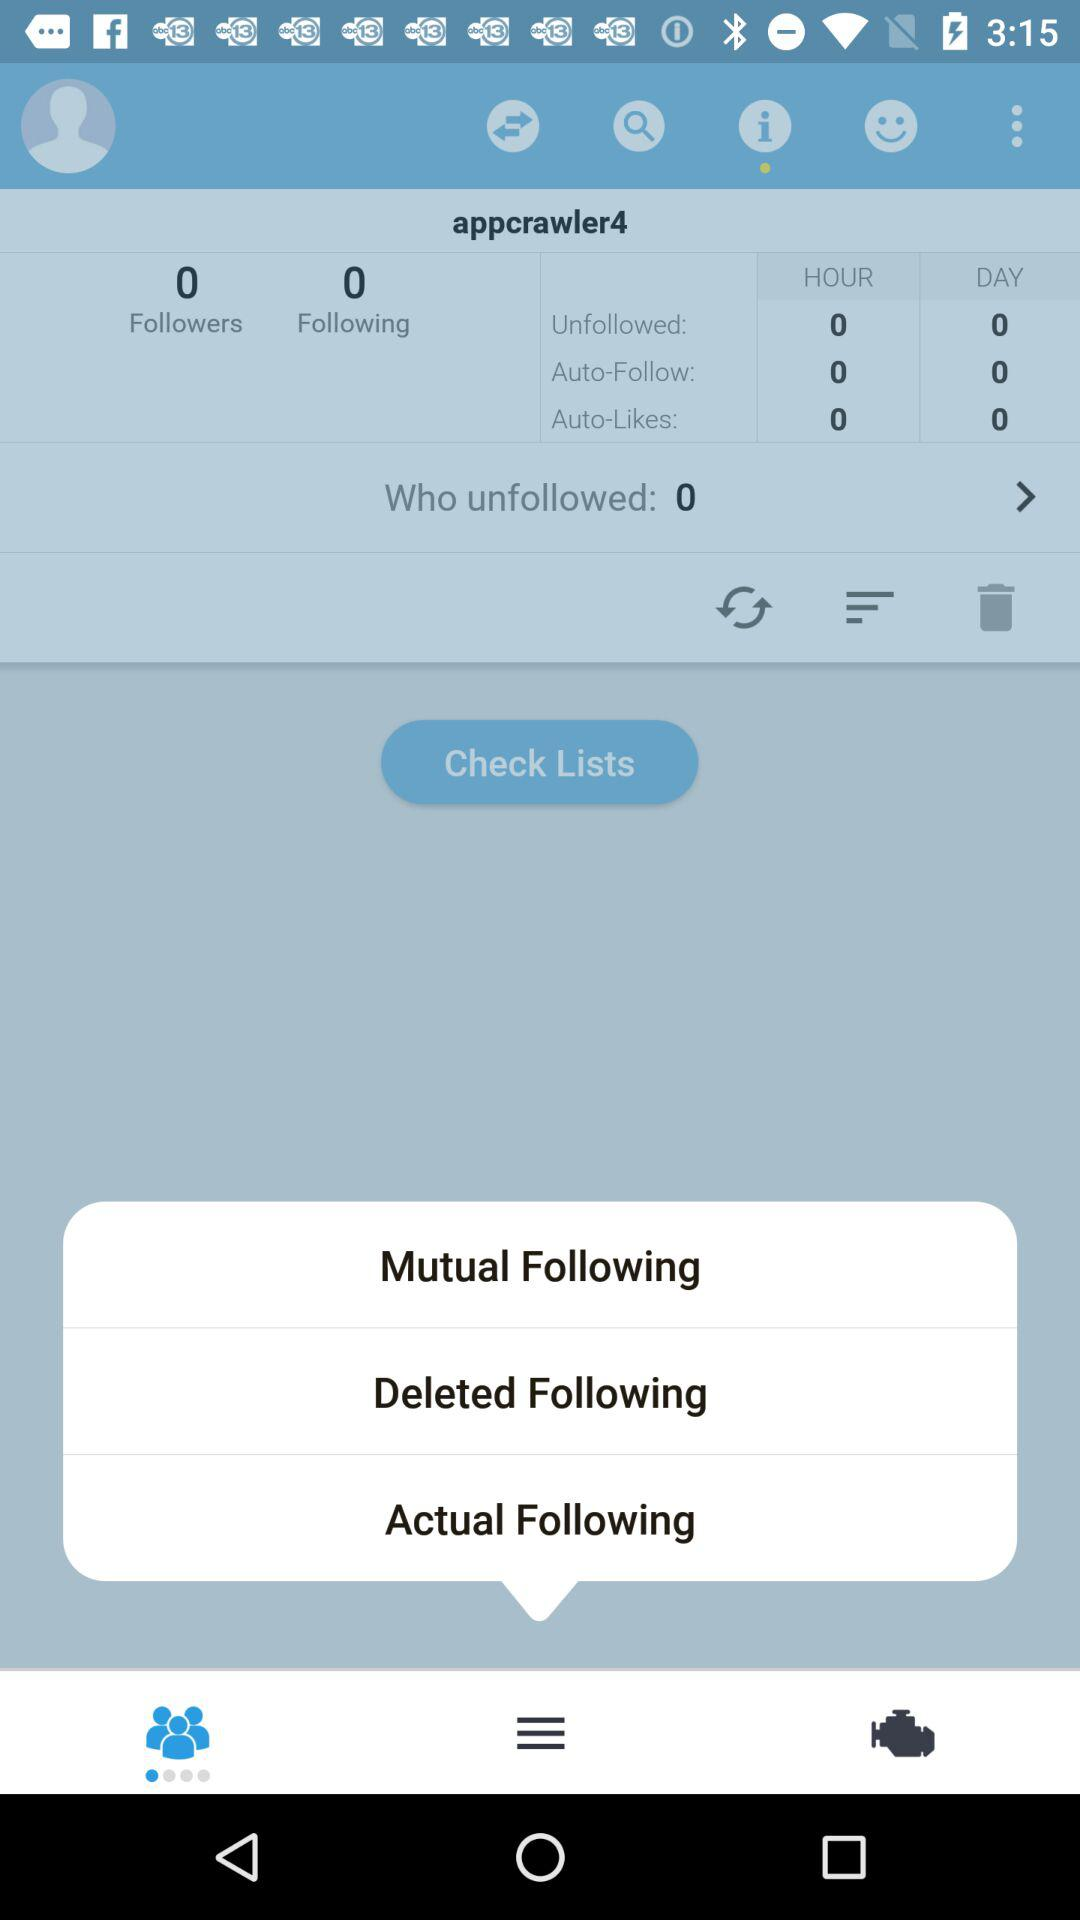What is the username? The username is "appcrawler4". 